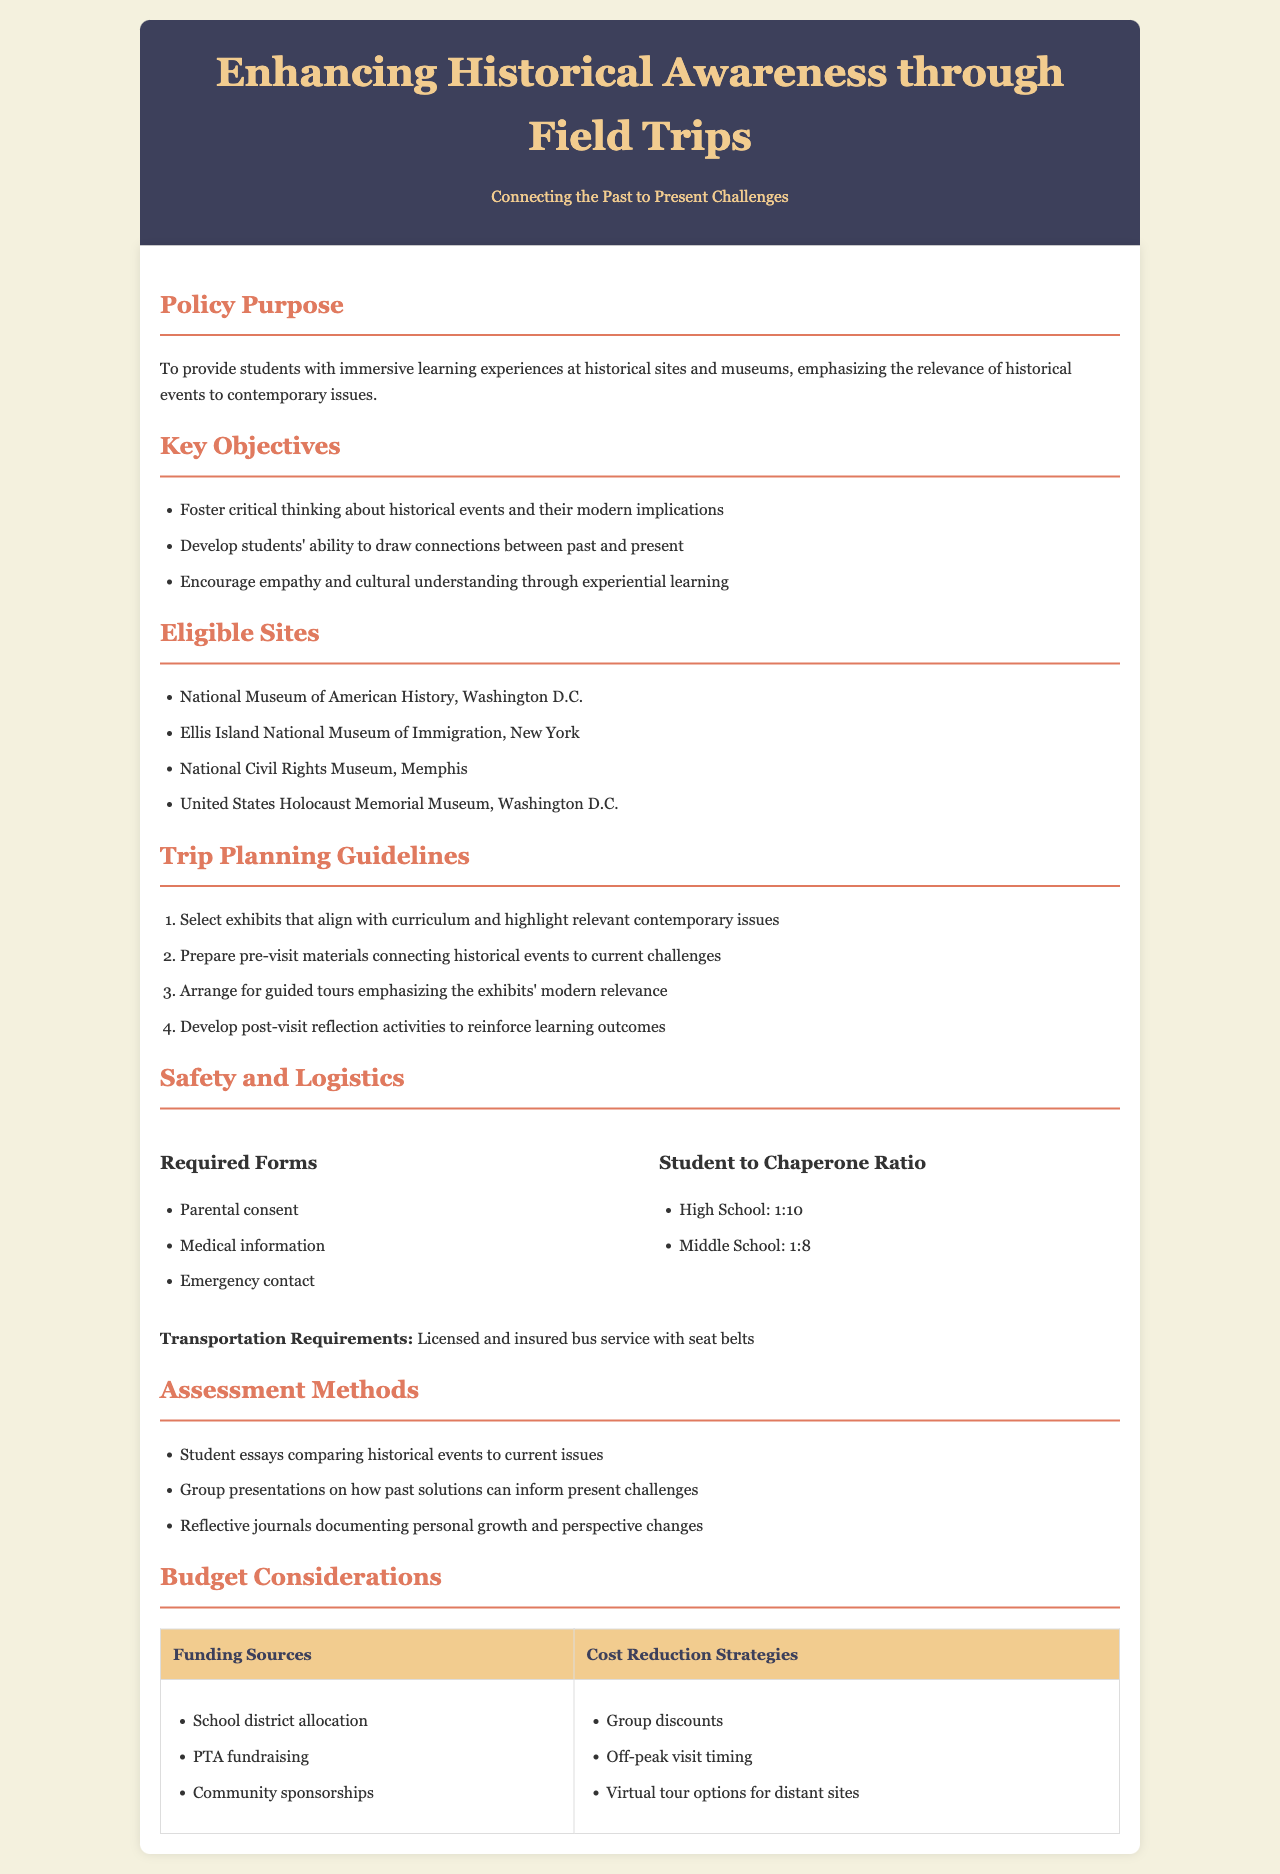What is the main purpose of the policy? The main purpose of the policy is to provide students with immersive learning experiences at historical sites and museums, emphasizing the relevance of historical events to contemporary issues.
Answer: To provide students with immersive learning experiences at historical sites and museums, emphasizing the relevance of historical events to contemporary issues Which museum is eligible for field trips related to Civil Rights? The document lists the National Civil Rights Museum in Memphis as an eligible site for field trips related to Civil Rights.
Answer: National Civil Rights Museum, Memphis What should be prepared before the visit to enhance learning? Pre-visit materials that connect historical events to current challenges should be prepared to enhance learning.
Answer: Pre-visit materials connecting historical events to current challenges What is the student to chaperone ratio for middle school? The student to chaperone ratio for middle school is outlined in the document and is set at 1:8.
Answer: 1:8 What type of assessment is suggested for students? The document suggests student essays comparing historical events to current issues as a method of assessment.
Answer: Student essays comparing historical events to current issues What is a cost reduction strategy mentioned in the document? One cost reduction strategy mentioned is utilizing group discounts for field trips.
Answer: Group discounts How many eligible sites are listed in total? The total number of eligible sites listed in the document is four, which are specified in the Eligible Sites section.
Answer: Four What is required for transportation to the field trip? The document specifies that licensed and insured bus service with seat belts is required for transportation.
Answer: Licensed and insured bus service with seat belts What is an objective of the field trips according to the policy? An objective noted in the policy is to develop students' ability to draw connections between past and present.
Answer: Develop students' ability to draw connections between past and present 